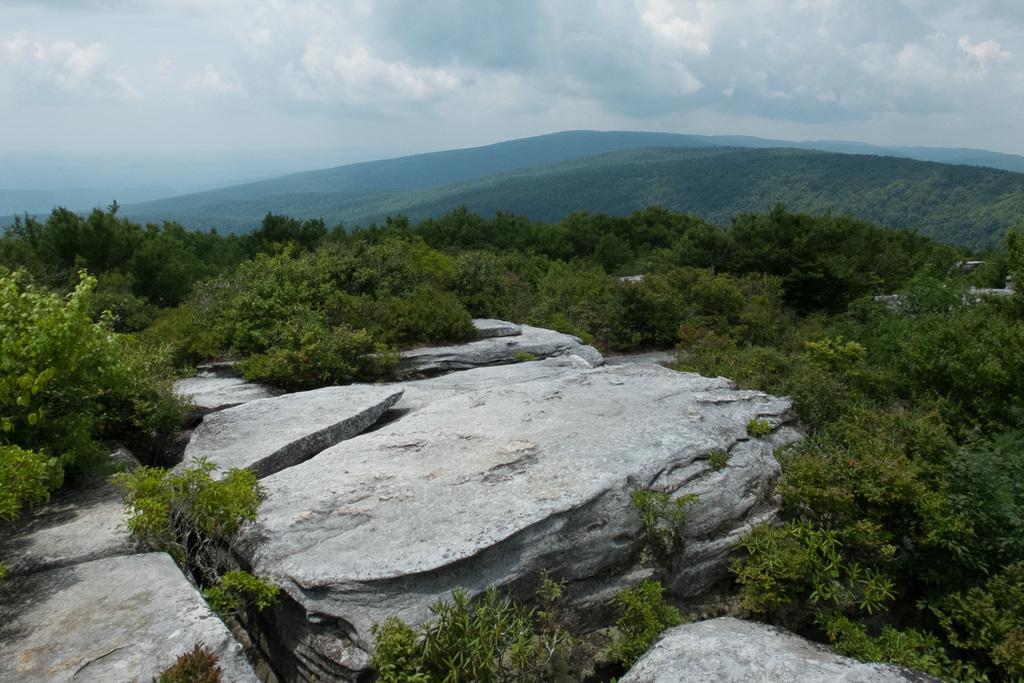Could you give a brief overview of what you see in this image? In the foreground of this image, there are rocks and trees. In the background, there are mountains, sky and the cloud. 